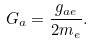<formula> <loc_0><loc_0><loc_500><loc_500>G _ { a } = \frac { g _ { a e } } { 2 m _ { e } } .</formula> 